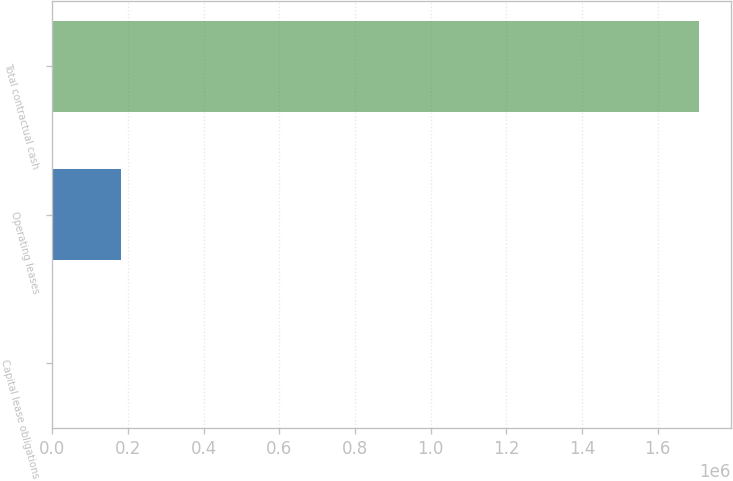Convert chart to OTSL. <chart><loc_0><loc_0><loc_500><loc_500><bar_chart><fcel>Capital lease obligations<fcel>Operating leases<fcel>Total contractual cash<nl><fcel>690<fcel>181800<fcel>1.70803e+06<nl></chart> 